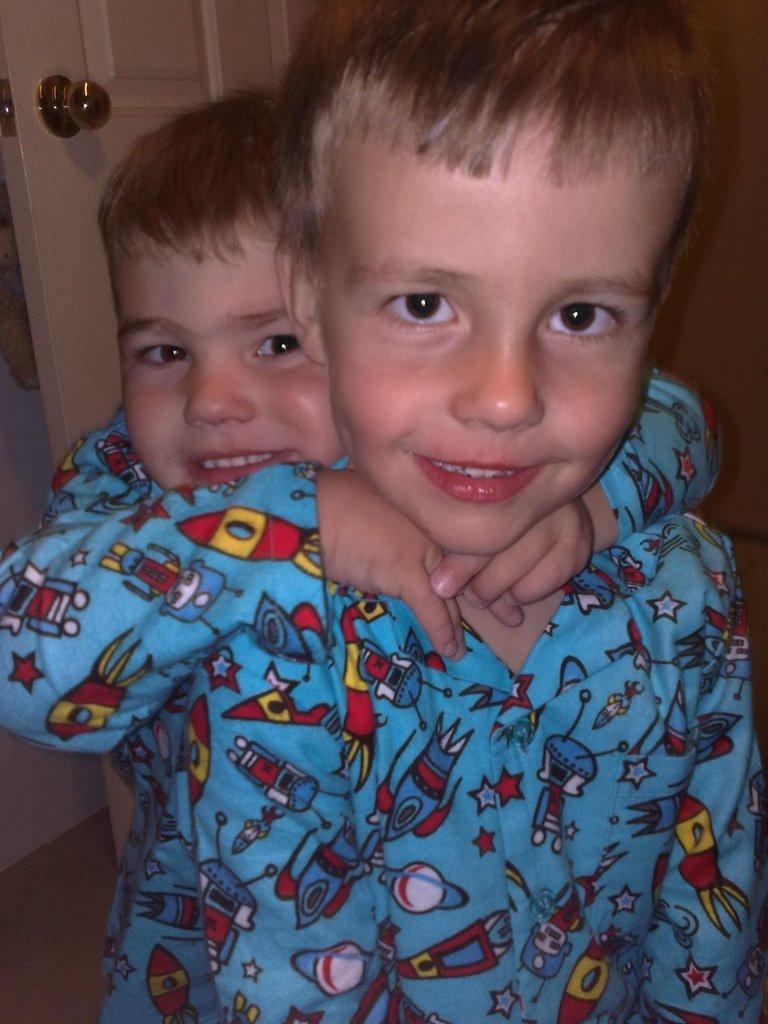How many people are in the image? There are two people in the image. What colors are the dresses worn by the people in the image? One person is wearing a blue dress, one person is wearing a red dress, one person is wearing a yellow dress, and one person is wearing a white dress. What can be seen in the background of the image? There is a door and a wall in the background of the image. What type of silver air can be seen floating in the image? There is no silver air or any floating objects present in the image. 